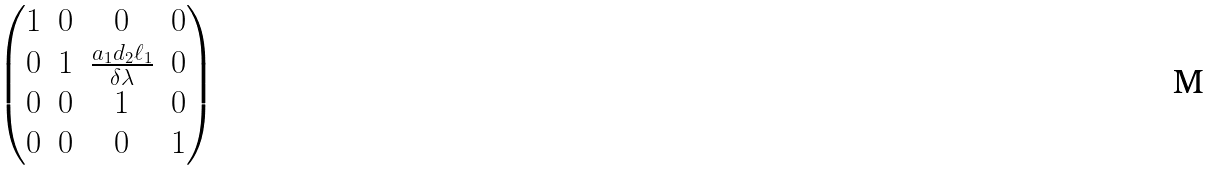Convert formula to latex. <formula><loc_0><loc_0><loc_500><loc_500>\begin{pmatrix} 1 & 0 & 0 & 0 \\ 0 & 1 & \frac { a _ { 1 } d _ { 2 } \ell _ { 1 } } { \delta \lambda } & 0 \\ 0 & 0 & 1 & 0 \\ 0 & 0 & 0 & 1 \end{pmatrix}</formula> 